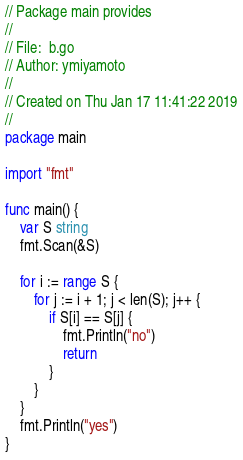<code> <loc_0><loc_0><loc_500><loc_500><_Go_>// Package main provides
//
// File:  b.go
// Author: ymiyamoto
//
// Created on Thu Jan 17 11:41:22 2019
//
package main

import "fmt"

func main() {
	var S string
	fmt.Scan(&S)

	for i := range S {
		for j := i + 1; j < len(S); j++ {
			if S[i] == S[j] {
				fmt.Println("no")
				return
			}
		}
	}
	fmt.Println("yes")
}
</code> 